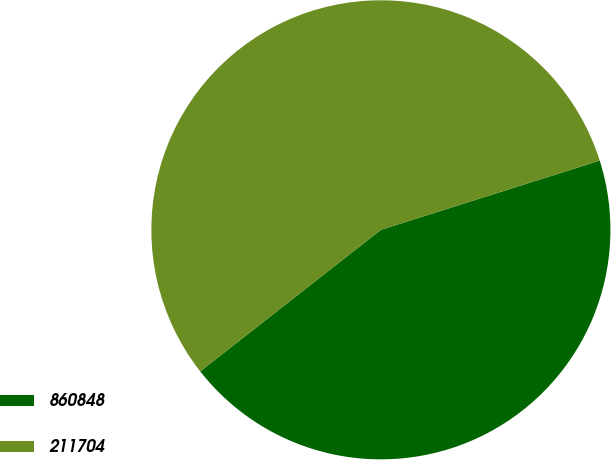Convert chart to OTSL. <chart><loc_0><loc_0><loc_500><loc_500><pie_chart><fcel>860848<fcel>211704<nl><fcel>44.3%<fcel>55.7%<nl></chart> 